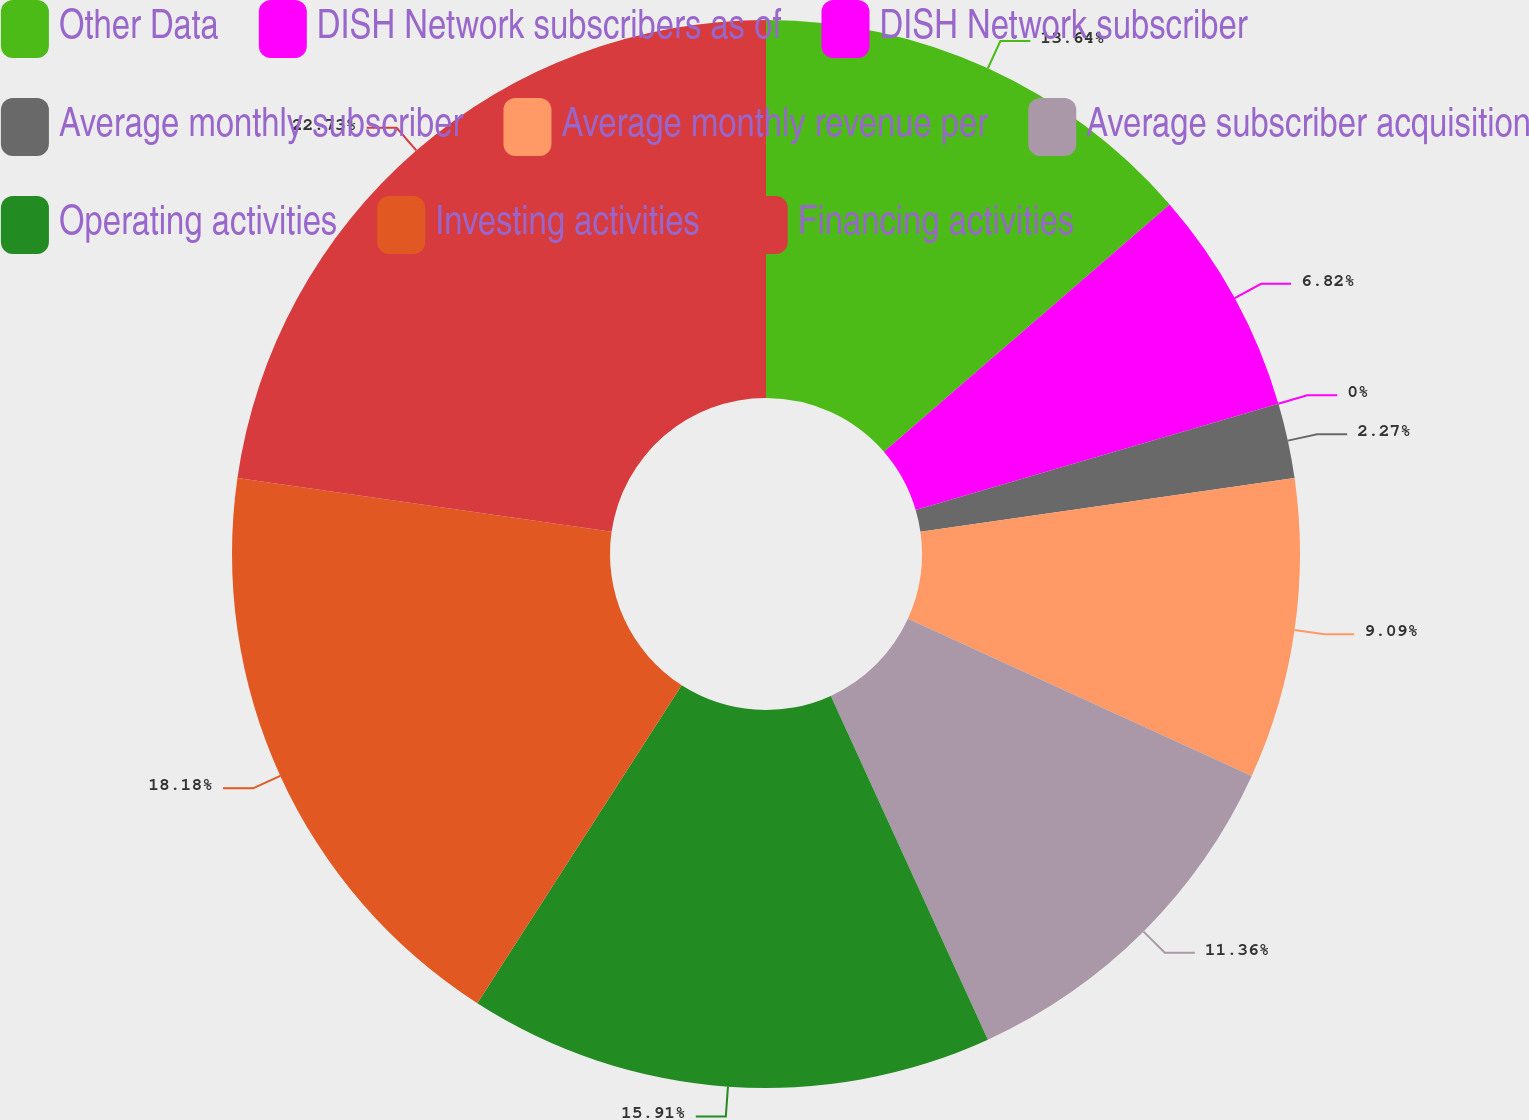Convert chart. <chart><loc_0><loc_0><loc_500><loc_500><pie_chart><fcel>Other Data<fcel>DISH Network subscribers as of<fcel>DISH Network subscriber<fcel>Average monthly subscriber<fcel>Average monthly revenue per<fcel>Average subscriber acquisition<fcel>Operating activities<fcel>Investing activities<fcel>Financing activities<nl><fcel>13.64%<fcel>6.82%<fcel>0.0%<fcel>2.27%<fcel>9.09%<fcel>11.36%<fcel>15.91%<fcel>18.18%<fcel>22.73%<nl></chart> 